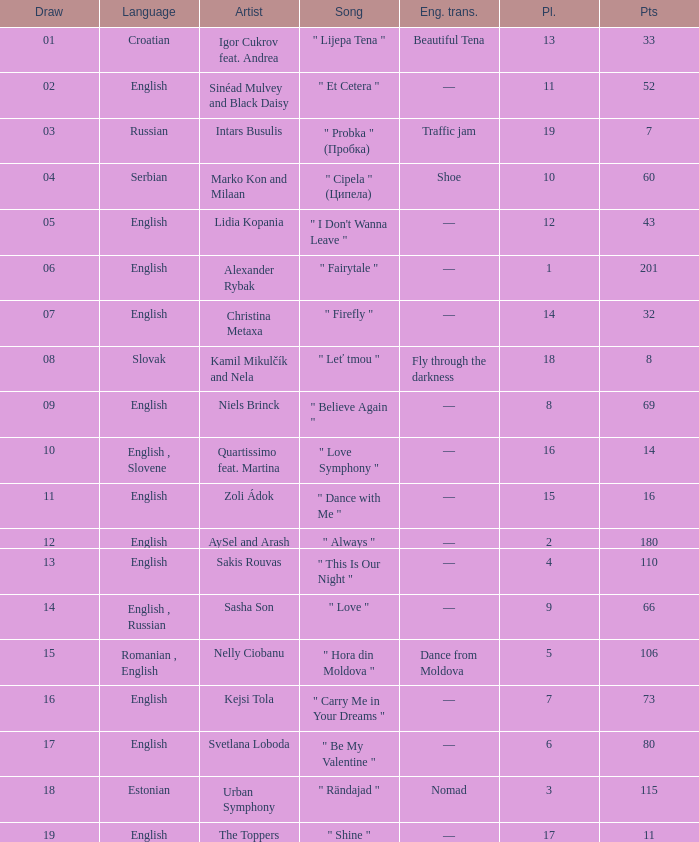What is the place when the draw is less than 12 and the artist is quartissimo feat. martina? 16.0. 